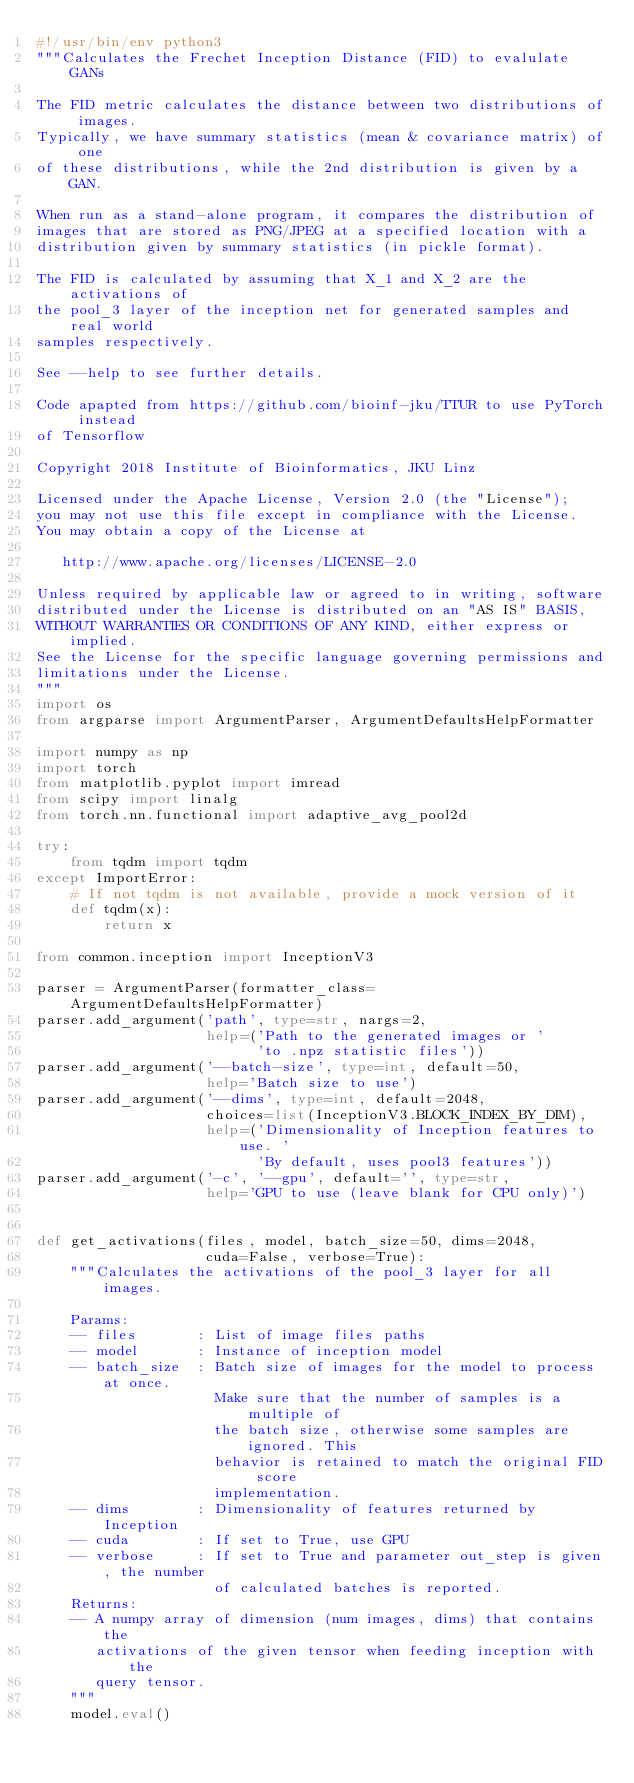Convert code to text. <code><loc_0><loc_0><loc_500><loc_500><_Python_>#!/usr/bin/env python3
"""Calculates the Frechet Inception Distance (FID) to evalulate GANs

The FID metric calculates the distance between two distributions of images.
Typically, we have summary statistics (mean & covariance matrix) of one
of these distributions, while the 2nd distribution is given by a GAN.

When run as a stand-alone program, it compares the distribution of
images that are stored as PNG/JPEG at a specified location with a
distribution given by summary statistics (in pickle format).

The FID is calculated by assuming that X_1 and X_2 are the activations of
the pool_3 layer of the inception net for generated samples and real world
samples respectively.

See --help to see further details.

Code apapted from https://github.com/bioinf-jku/TTUR to use PyTorch instead
of Tensorflow

Copyright 2018 Institute of Bioinformatics, JKU Linz

Licensed under the Apache License, Version 2.0 (the "License");
you may not use this file except in compliance with the License.
You may obtain a copy of the License at

   http://www.apache.org/licenses/LICENSE-2.0

Unless required by applicable law or agreed to in writing, software
distributed under the License is distributed on an "AS IS" BASIS,
WITHOUT WARRANTIES OR CONDITIONS OF ANY KIND, either express or implied.
See the License for the specific language governing permissions and
limitations under the License.
"""
import os
from argparse import ArgumentParser, ArgumentDefaultsHelpFormatter

import numpy as np
import torch
from matplotlib.pyplot import imread
from scipy import linalg
from torch.nn.functional import adaptive_avg_pool2d

try:
    from tqdm import tqdm
except ImportError:
    # If not tqdm is not available, provide a mock version of it
    def tqdm(x):
        return x

from common.inception import InceptionV3

parser = ArgumentParser(formatter_class=ArgumentDefaultsHelpFormatter)
parser.add_argument('path', type=str, nargs=2,
                    help=('Path to the generated images or '
                          'to .npz statistic files'))
parser.add_argument('--batch-size', type=int, default=50,
                    help='Batch size to use')
parser.add_argument('--dims', type=int, default=2048,
                    choices=list(InceptionV3.BLOCK_INDEX_BY_DIM),
                    help=('Dimensionality of Inception features to use. '
                          'By default, uses pool3 features'))
parser.add_argument('-c', '--gpu', default='', type=str,
                    help='GPU to use (leave blank for CPU only)')


def get_activations(files, model, batch_size=50, dims=2048,
                    cuda=False, verbose=True):
    """Calculates the activations of the pool_3 layer for all images.

    Params:
    -- files       : List of image files paths
    -- model       : Instance of inception model
    -- batch_size  : Batch size of images for the model to process at once.
                     Make sure that the number of samples is a multiple of
                     the batch size, otherwise some samples are ignored. This
                     behavior is retained to match the original FID score
                     implementation.
    -- dims        : Dimensionality of features returned by Inception
    -- cuda        : If set to True, use GPU
    -- verbose     : If set to True and parameter out_step is given, the number
                     of calculated batches is reported.
    Returns:
    -- A numpy array of dimension (num images, dims) that contains the
       activations of the given tensor when feeding inception with the
       query tensor.
    """
    model.eval()
</code> 